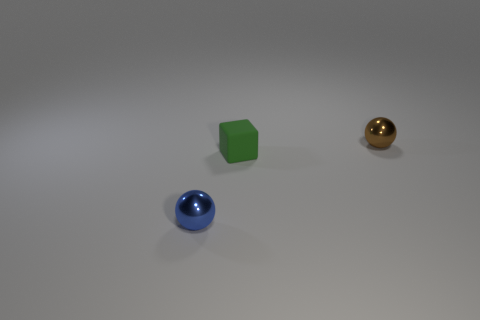What color is the tiny metallic object in front of the tiny brown thing? The small metallic object appears to be blue, standing in front of a larger brown spherical object which might be mistaken as tiny due to perspective. 